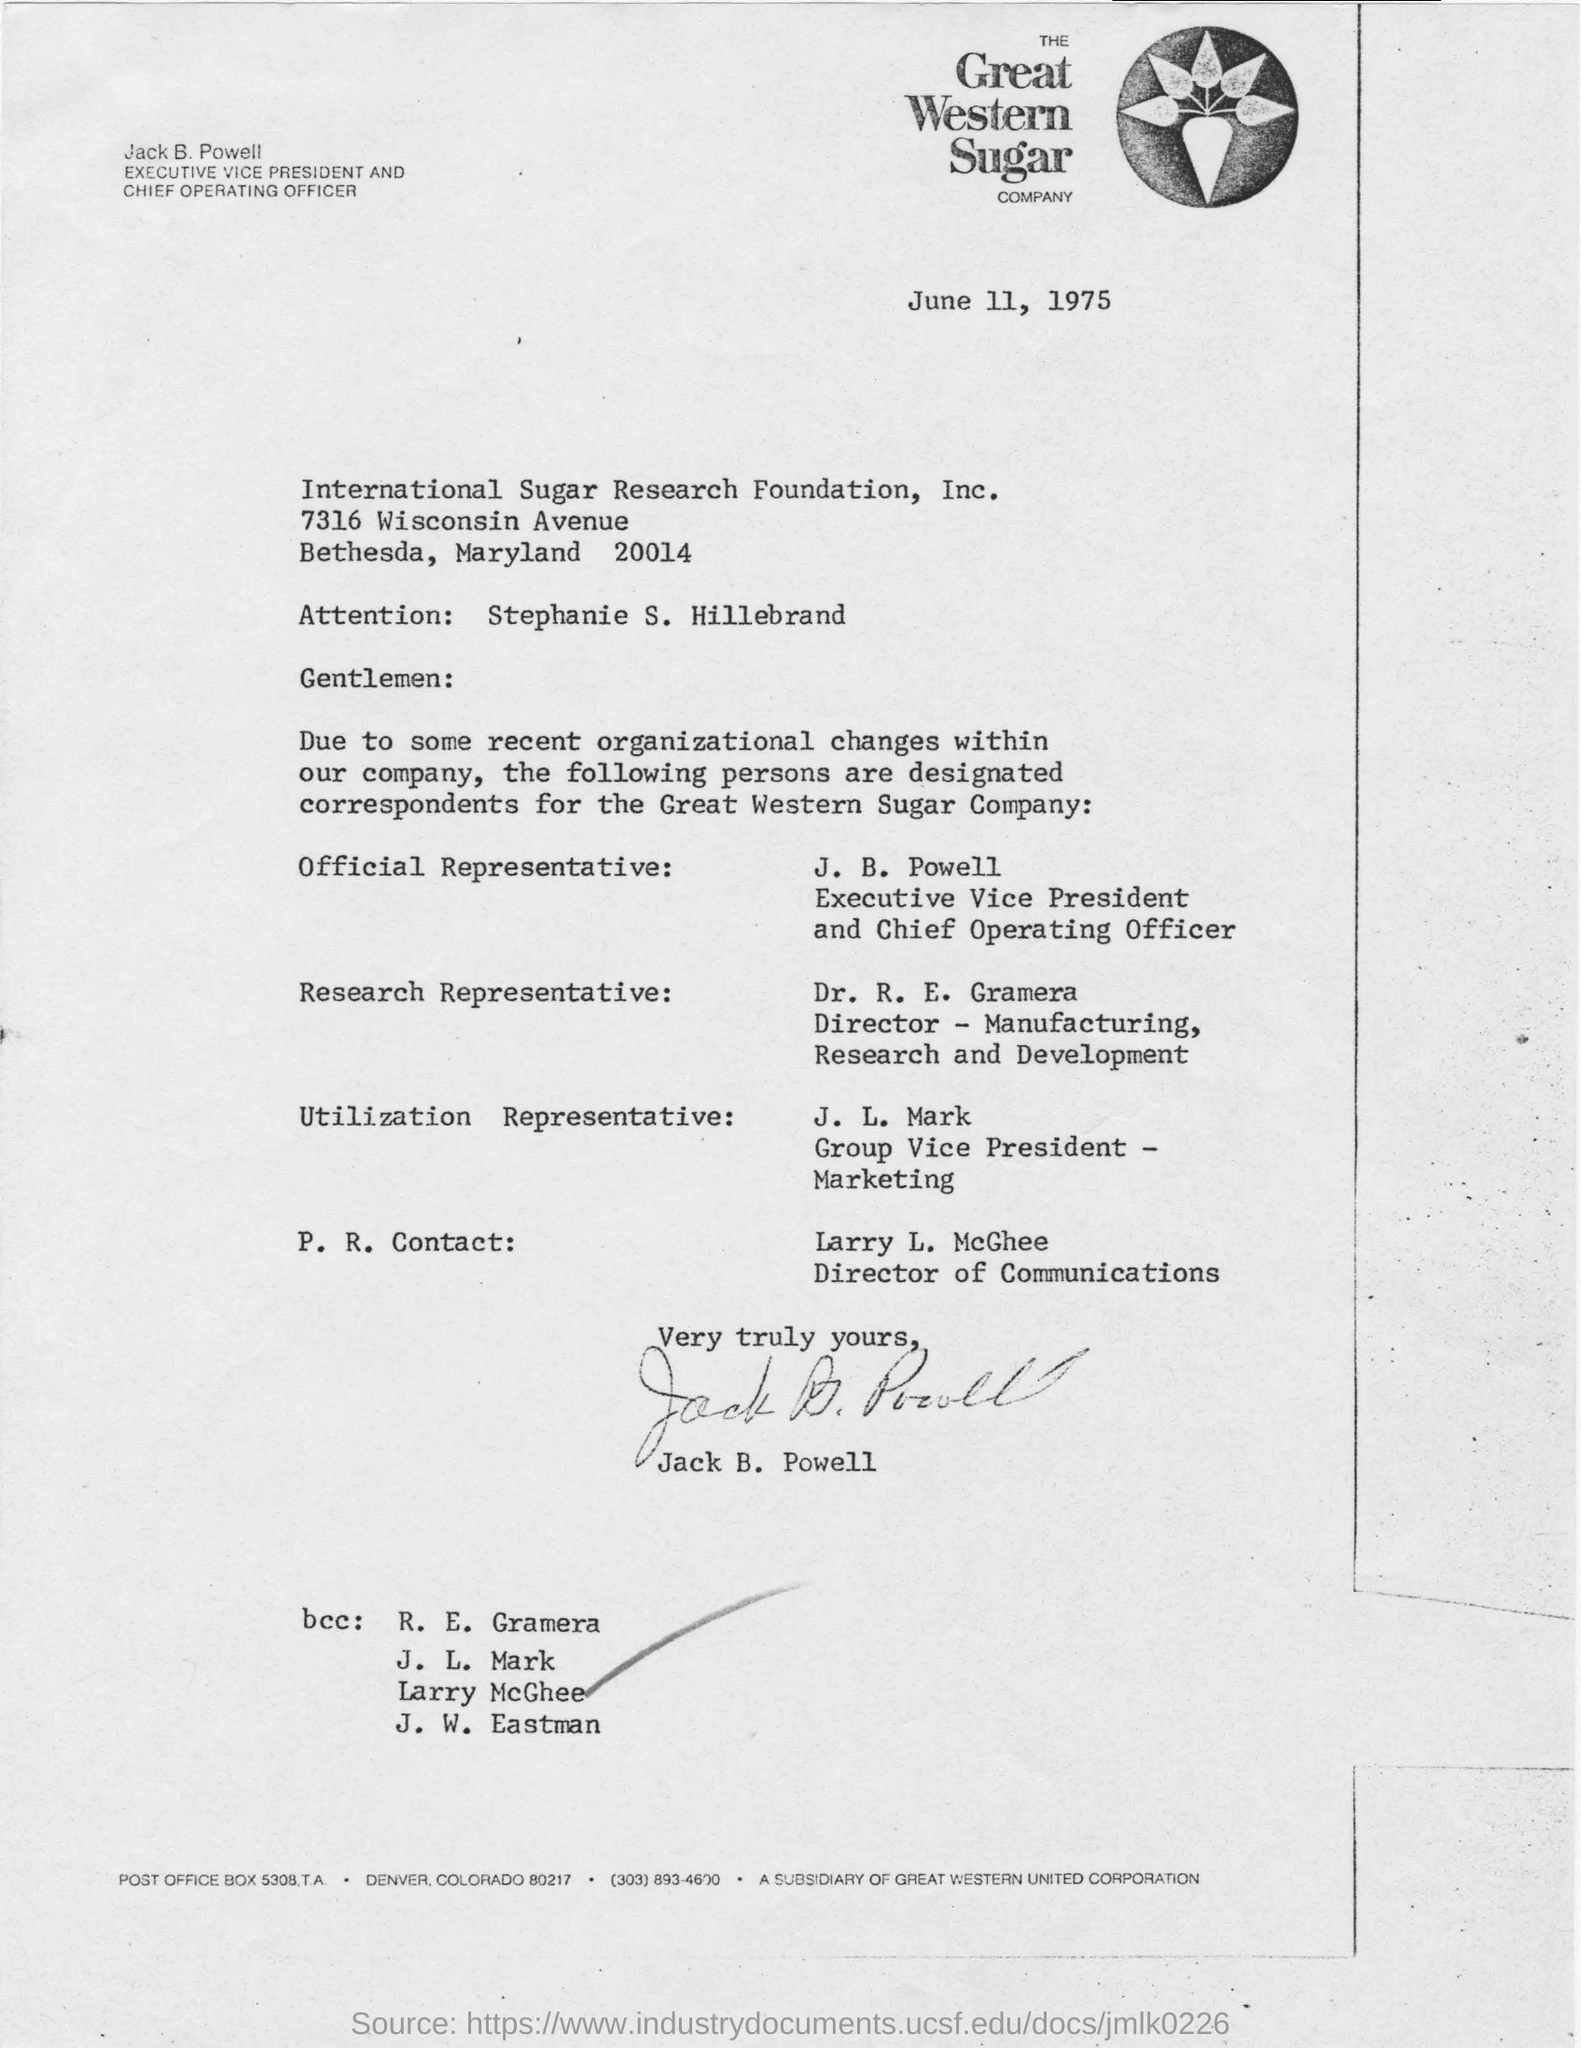Identify some key points in this picture. J. B. Powell holds the designation of Executive Vice President and Chief Operating Officer. The Director of Communications is named Larry L. McGhee. The letter, dated June 11, 1975, is asking for a copy of the work manual. Jack B. Powell has signed the letter. 